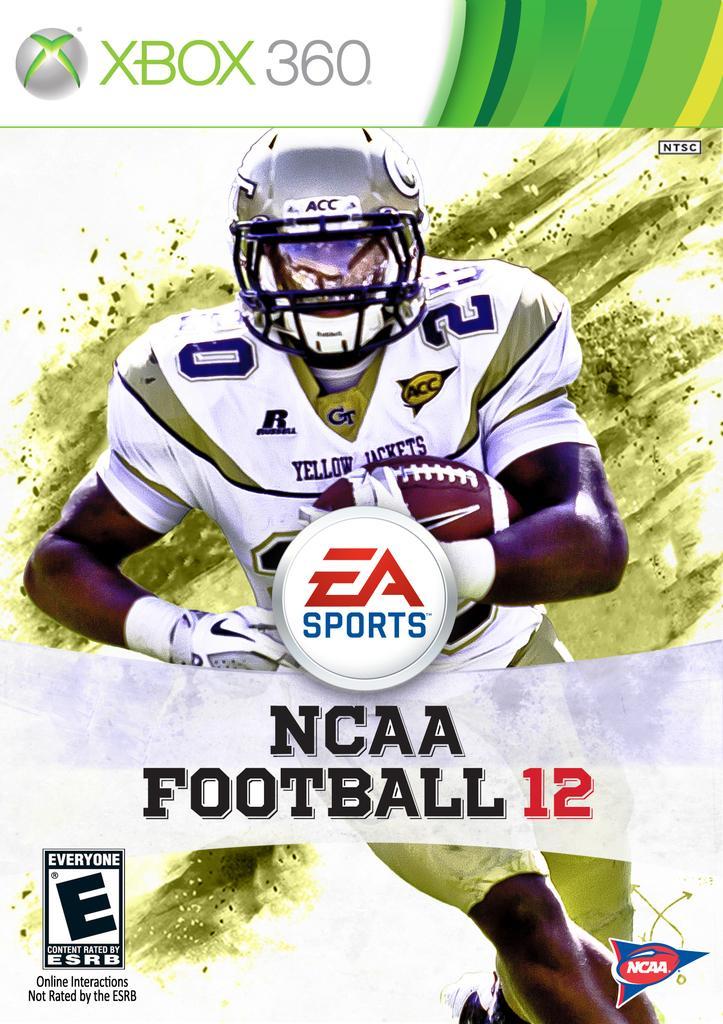Could you give a brief overview of what you see in this image? This is a graphic image of a person holding a rugby ball with text in the middle and above it. 